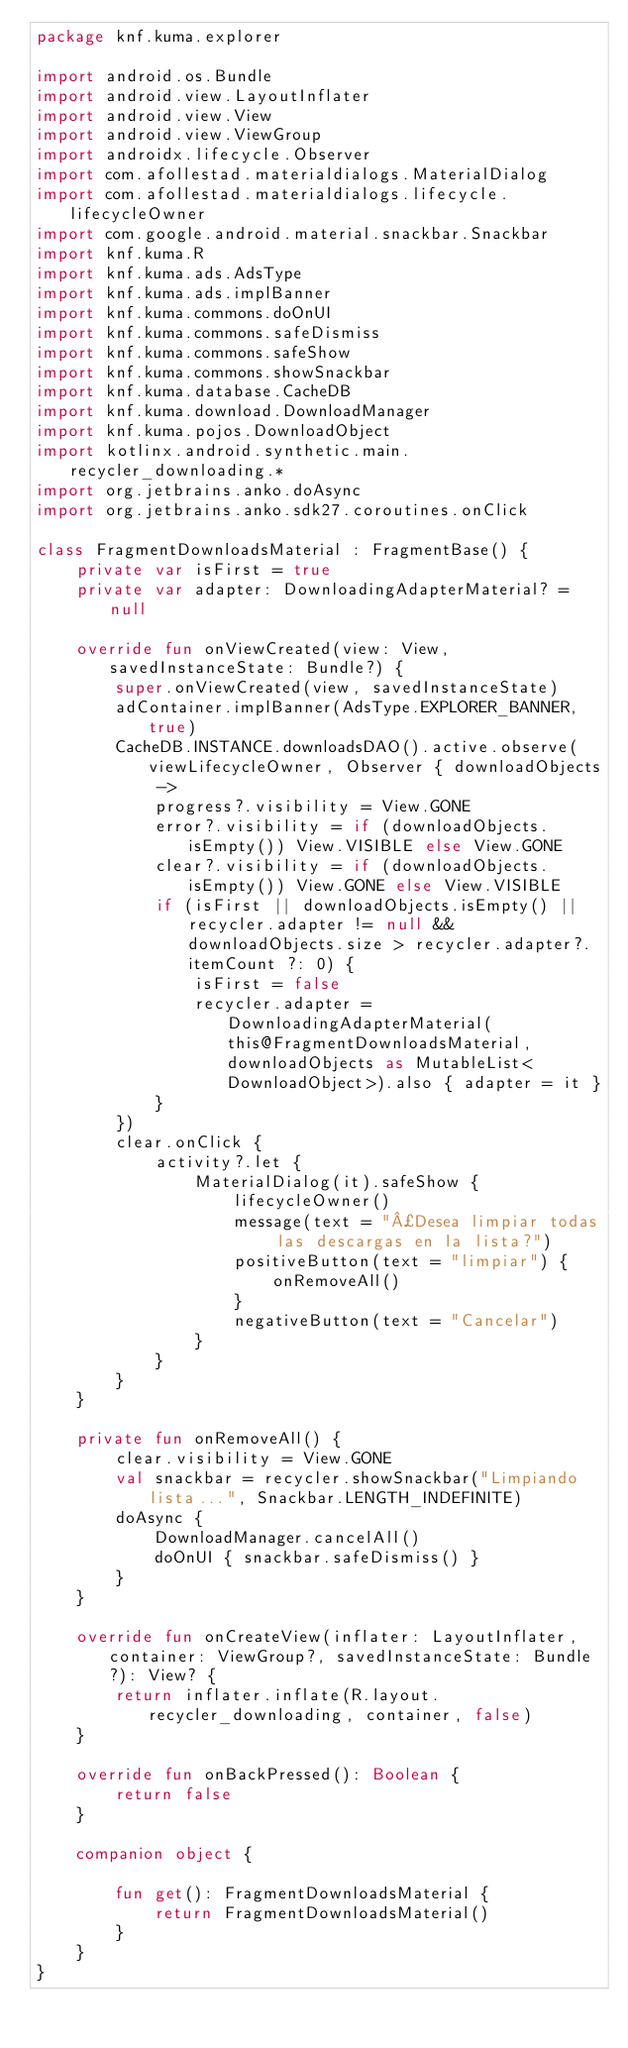Convert code to text. <code><loc_0><loc_0><loc_500><loc_500><_Kotlin_>package knf.kuma.explorer

import android.os.Bundle
import android.view.LayoutInflater
import android.view.View
import android.view.ViewGroup
import androidx.lifecycle.Observer
import com.afollestad.materialdialogs.MaterialDialog
import com.afollestad.materialdialogs.lifecycle.lifecycleOwner
import com.google.android.material.snackbar.Snackbar
import knf.kuma.R
import knf.kuma.ads.AdsType
import knf.kuma.ads.implBanner
import knf.kuma.commons.doOnUI
import knf.kuma.commons.safeDismiss
import knf.kuma.commons.safeShow
import knf.kuma.commons.showSnackbar
import knf.kuma.database.CacheDB
import knf.kuma.download.DownloadManager
import knf.kuma.pojos.DownloadObject
import kotlinx.android.synthetic.main.recycler_downloading.*
import org.jetbrains.anko.doAsync
import org.jetbrains.anko.sdk27.coroutines.onClick

class FragmentDownloadsMaterial : FragmentBase() {
    private var isFirst = true
    private var adapter: DownloadingAdapterMaterial? = null

    override fun onViewCreated(view: View, savedInstanceState: Bundle?) {
        super.onViewCreated(view, savedInstanceState)
        adContainer.implBanner(AdsType.EXPLORER_BANNER, true)
        CacheDB.INSTANCE.downloadsDAO().active.observe(viewLifecycleOwner, Observer { downloadObjects ->
            progress?.visibility = View.GONE
            error?.visibility = if (downloadObjects.isEmpty()) View.VISIBLE else View.GONE
            clear?.visibility = if (downloadObjects.isEmpty()) View.GONE else View.VISIBLE
            if (isFirst || downloadObjects.isEmpty() || recycler.adapter != null && downloadObjects.size > recycler.adapter?.itemCount ?: 0) {
                isFirst = false
                recycler.adapter = DownloadingAdapterMaterial(this@FragmentDownloadsMaterial, downloadObjects as MutableList<DownloadObject>).also { adapter = it }
            }
        })
        clear.onClick {
            activity?.let {
                MaterialDialog(it).safeShow {
                    lifecycleOwner()
                    message(text = "¿Desea limpiar todas las descargas en la lista?")
                    positiveButton(text = "limpiar") {
                        onRemoveAll()
                    }
                    negativeButton(text = "Cancelar")
                }
            }
        }
    }

    private fun onRemoveAll() {
        clear.visibility = View.GONE
        val snackbar = recycler.showSnackbar("Limpiando lista...", Snackbar.LENGTH_INDEFINITE)
        doAsync {
            DownloadManager.cancelAll()
            doOnUI { snackbar.safeDismiss() }
        }
    }

    override fun onCreateView(inflater: LayoutInflater, container: ViewGroup?, savedInstanceState: Bundle?): View? {
        return inflater.inflate(R.layout.recycler_downloading, container, false)
    }

    override fun onBackPressed(): Boolean {
        return false
    }

    companion object {

        fun get(): FragmentDownloadsMaterial {
            return FragmentDownloadsMaterial()
        }
    }
}
</code> 